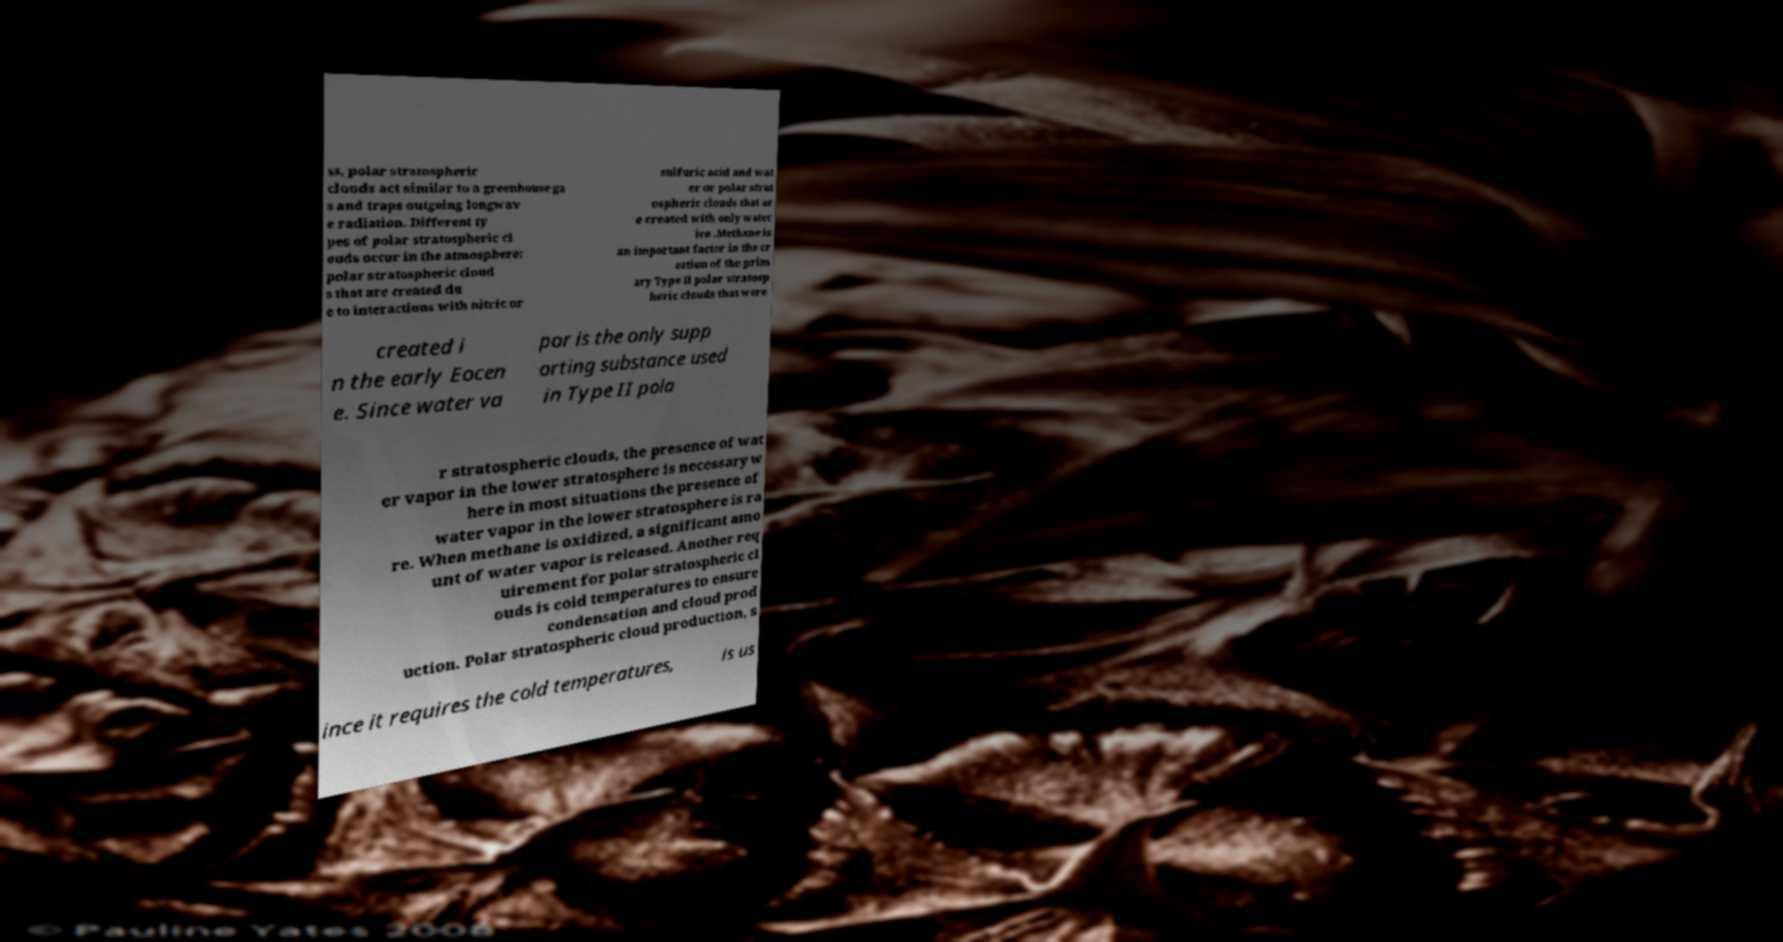Can you read and provide the text displayed in the image?This photo seems to have some interesting text. Can you extract and type it out for me? ss, polar stratospheric clouds act similar to a greenhouse ga s and traps outgoing longwav e radiation. Different ty pes of polar stratospheric cl ouds occur in the atmosphere: polar stratospheric cloud s that are created du e to interactions with nitric or sulfuric acid and wat er or polar strat ospheric clouds that ar e created with only water ice .Methane is an important factor in the cr eation of the prim ary Type II polar stratosp heric clouds that were created i n the early Eocen e. Since water va por is the only supp orting substance used in Type II pola r stratospheric clouds, the presence of wat er vapor in the lower stratosphere is necessary w here in most situations the presence of water vapor in the lower stratosphere is ra re. When methane is oxidized, a significant amo unt of water vapor is released. Another req uirement for polar stratospheric cl ouds is cold temperatures to ensure condensation and cloud prod uction. Polar stratospheric cloud production, s ince it requires the cold temperatures, is us 